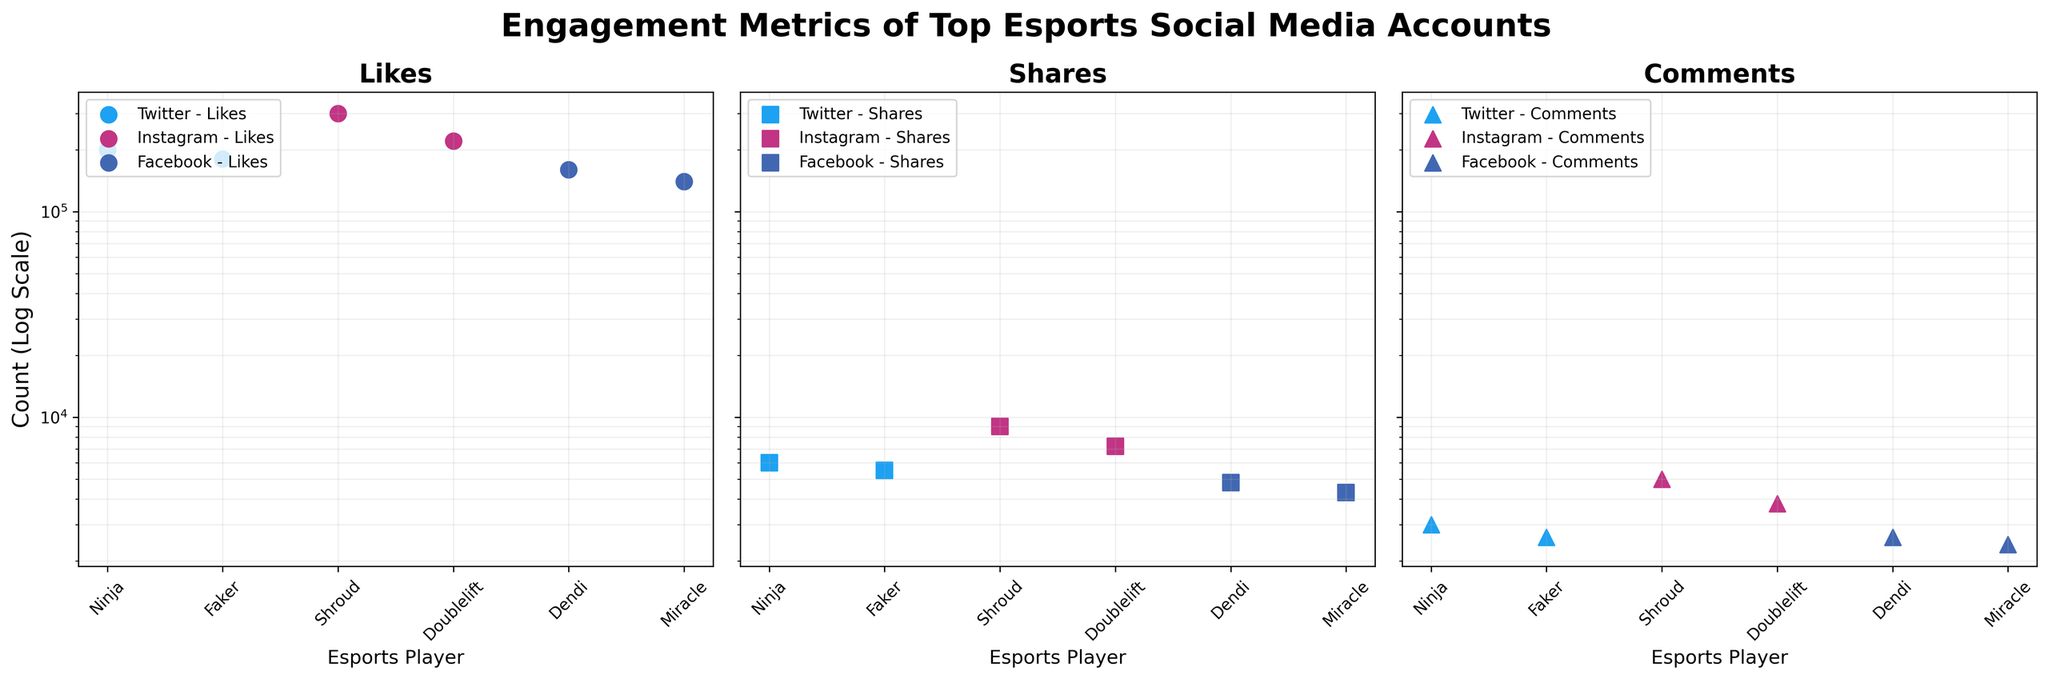what's the color used for Twitter accounts? The color representing Twitter accounts is visually distinct in the plot. By observing, it is a light blue color.
Answer: Light blue How many engagement metrics are displayed for each type of social media account? There are three subplots, each representing a different engagement metric: Likes, Shares, and Comments. This applies to all social media accounts shown.
Answer: 3 Which platform's player has the maximum number of Likes? Among the spots, the player with the highest Likes should have the highest point in the Likes subplot. The orange spot, representing Shroud on Instagram, appears to be the highest.
Answer: Instagram (Shroud) For Twitter accounts, compare the number of shares between Ninja and Faker. By observing the Shares subplot, compare the heights of Ninja's and Faker's points in the light blue color group. Ninja's Shares are higher than Faker's.
Answer: Ninja > Faker What is the general trend in the number of comments compared to likes for Facebook accounts? In the Comments subplot, the points are jointly lower than their corresponding points in the Likes subplot, indicating fewer comments as compared to likes for Facebook accounts.
Answer: Fewer comments than likes What metric has the highest engagement for Doublelift on Instagram? Locate Doublelift's points in the Instagram color (pink) in all three subplots. Check which metric subplot has the highest point. For Doublelift, the Likes subplot has the highest engagement.
Answer: Likes Which player has the lowest number of engagement metrics in the 'Shares' category across all platforms? In the Shares subplot, identify the lowest points. Miracle on Facebook appears to have the lowest number of Shares.
Answer: Miracle Which social media platform has relatively more balanced engagement metrics for its top account? Check each platform's representation across all three subplots and see which platform's accounts do not show drastic variations among Likes, Shares, and Comments. All metrics for Twitter appear closer compared to Instagram and Facebook.
Answer: Twitter On a logarithmic scale, which player's engagement in Comments on Instagram has higher elevation compared to their own engagement in Shares on Instagram? In the Comments subplot comparing heights of Shroud and Doublelift in the pink group, both players have higher comments counts than shares. Since the differences between Shroud's points are visibly notable, he stands out.
Answer: Shroud 